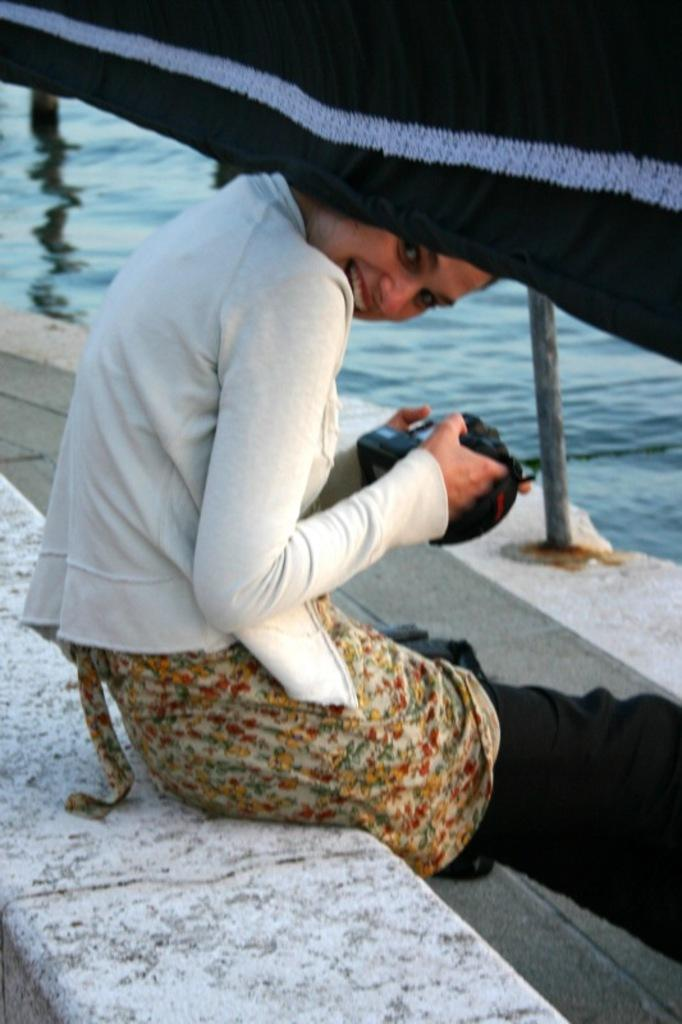Who is present in the image? There is a woman in the image. What is the woman doing in the image? The woman is sitting on the ground. What can be seen in the background of the image? There is water visible in the background of the image. How many deer can be seen in the image? There are no deer present in the image. What is the woman doing with her head in the image? The woman's head is not performing any action in the image; she is simply sitting on the ground. 